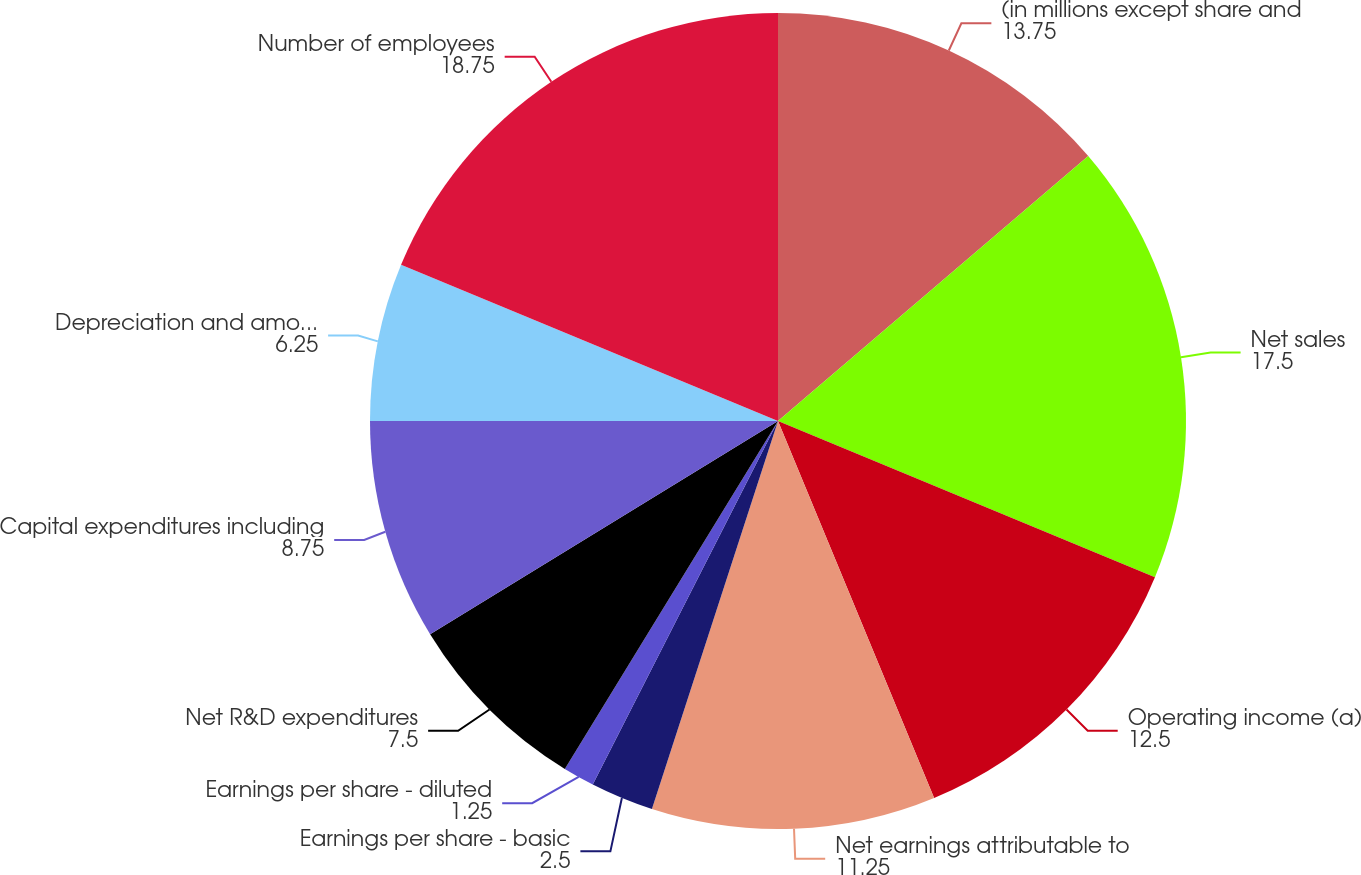<chart> <loc_0><loc_0><loc_500><loc_500><pie_chart><fcel>(in millions except share and<fcel>Net sales<fcel>Operating income (a)<fcel>Net earnings attributable to<fcel>Earnings per share - basic<fcel>Earnings per share - diluted<fcel>Net R&D expenditures<fcel>Capital expenditures including<fcel>Depreciation and amortization<fcel>Number of employees<nl><fcel>13.75%<fcel>17.5%<fcel>12.5%<fcel>11.25%<fcel>2.5%<fcel>1.25%<fcel>7.5%<fcel>8.75%<fcel>6.25%<fcel>18.75%<nl></chart> 